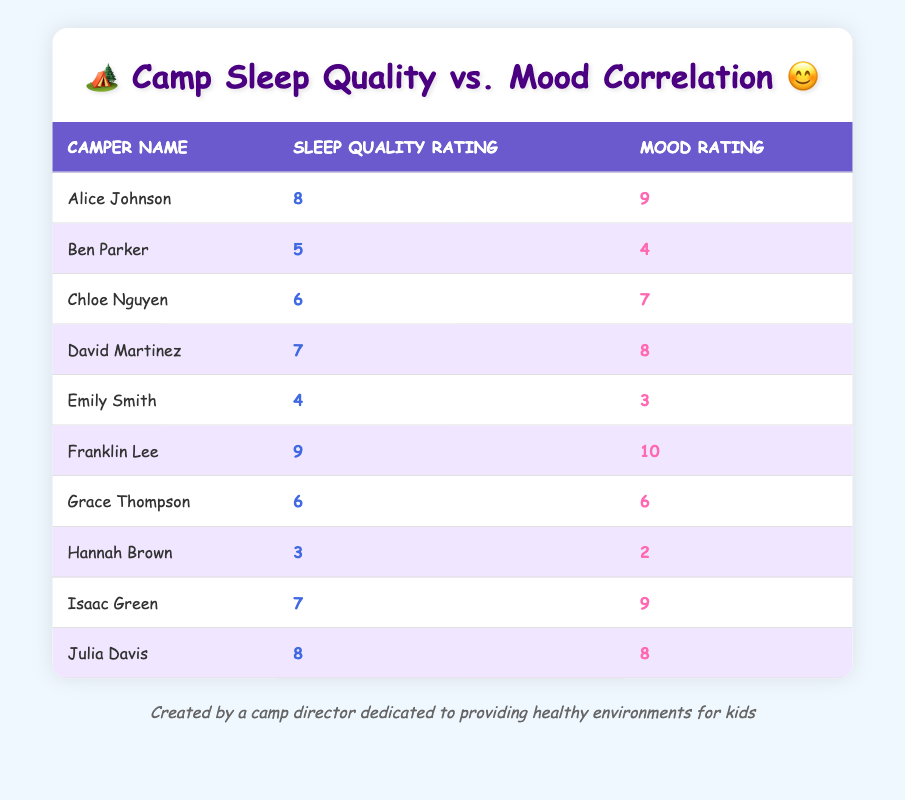What is the highest sleep quality rating among the campers? By examining the table, the highest sleep quality rating is found in Franklin Lee’s row, which shows a sleep quality rating of 9.
Answer: 9 Which camper has the lowest mood rating? Looking through the table, Hannah Brown has the lowest mood rating displayed, which is a 2.
Answer: 2 What is the average mood rating of all campers? First, sum all mood ratings: 9 + 4 + 7 + 8 + 3 + 10 + 6 + 2 + 9 + 8 = 66. There are 10 campers, so the average mood rating is 66 divided by 10, which equals 6.6.
Answer: 6.6 Is there a camper who rated both sleep quality and mood ratings the same? Reviewing the table, Grace Thompson rated both sleep quality and mood as 6. Therefore, yes, there is a camper who rated both the same.
Answer: Yes What is the difference between the highest and lowest sleep quality ratings? The highest sleep quality rating is 9 (Franklin Lee) and the lowest is 3 (Hannah Brown). The difference is calculated as 9 - 3 = 6.
Answer: 6 How many campers have a sleep quality rating of 7 or higher? By analyzing the table, the campers who have sleep quality ratings of 7 or higher are Franklin Lee (9), Alice Johnson (8), Isaac Green (7), and David Martinez (7), which totals to 4 campers.
Answer: 4 What was the mood rating for the camper who had a sleep quality rating of 5? Looking at Ben Parker’s row, his sleep quality rating is 5, and the corresponding mood rating is 4.
Answer: 4 Which camper had the most positive difference between sleep quality rating and mood rating? To find this, we calculate the difference (mood rating - sleep quality rating) for each camper. The camper with the largest positive difference is Franklin Lee: 10 - 9 = 1, which is the highest difference.
Answer: Franklin Lee What is the total of sleep quality ratings for campers with mood ratings above 7? The campers with mood ratings above 7 are Alice Johnson (8), David Martinez (8), Franklin Lee (10), Isaac Green (9), and Julia Davis (8). Their sleep quality ratings are 8, 7, 9, 7, and 8 respectively. The total is 8 + 7 + 9 + 7 + 8 = 39.
Answer: 39 